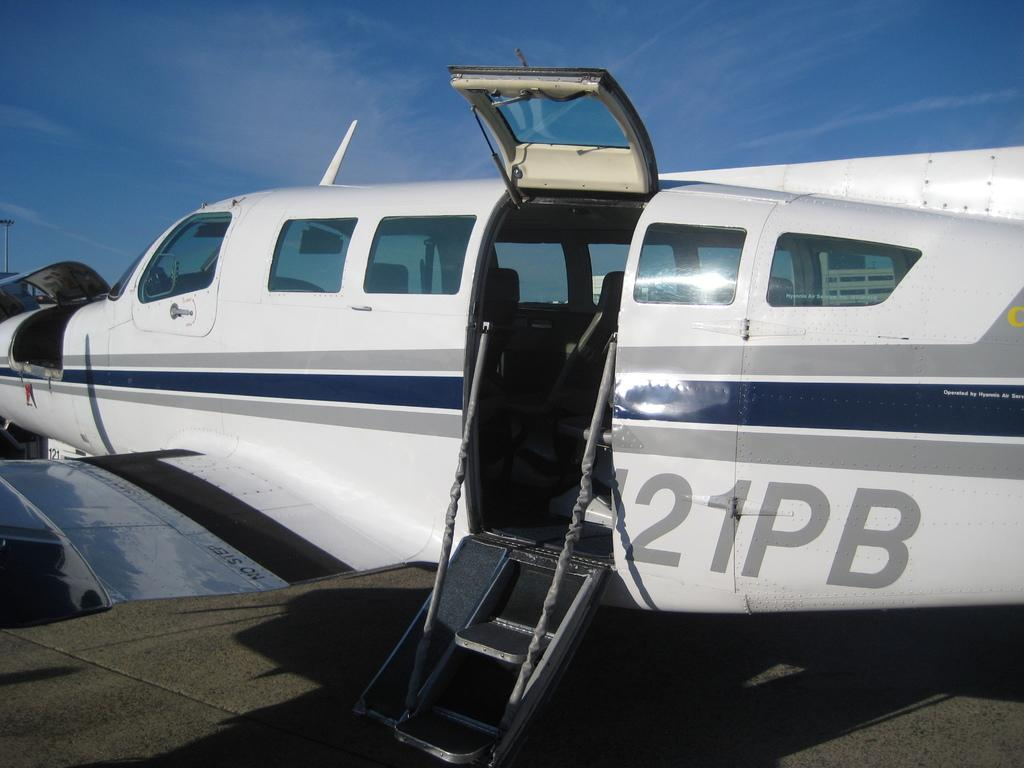What is the main subject of the image? The main subject of the image is an airplane. Where is the airplane located in the image? The airplane is on the ground in the image. What can be seen on the airplane's exterior? There are numbers and alphabets on the airplane. What is the status of the airplane's door? The door of the airplane is open. What is visible at the top of the image? The sky is visible at the top of the image. What is the size of the mist surrounding the airplane in the image? There is no mist present in the image; the airplane is on the ground with the door open and the sky visible at the top. What phase is the moon in, as seen in the image? There is no moon visible in the image; it only features an airplane on the ground with the door open and the sky visible at the top. 